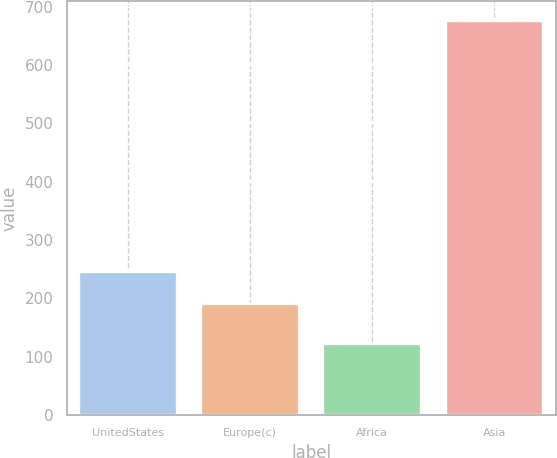<chart> <loc_0><loc_0><loc_500><loc_500><bar_chart><fcel>UnitedStates<fcel>Europe(c)<fcel>Africa<fcel>Asia<nl><fcel>245.4<fcel>190<fcel>122<fcel>676<nl></chart> 